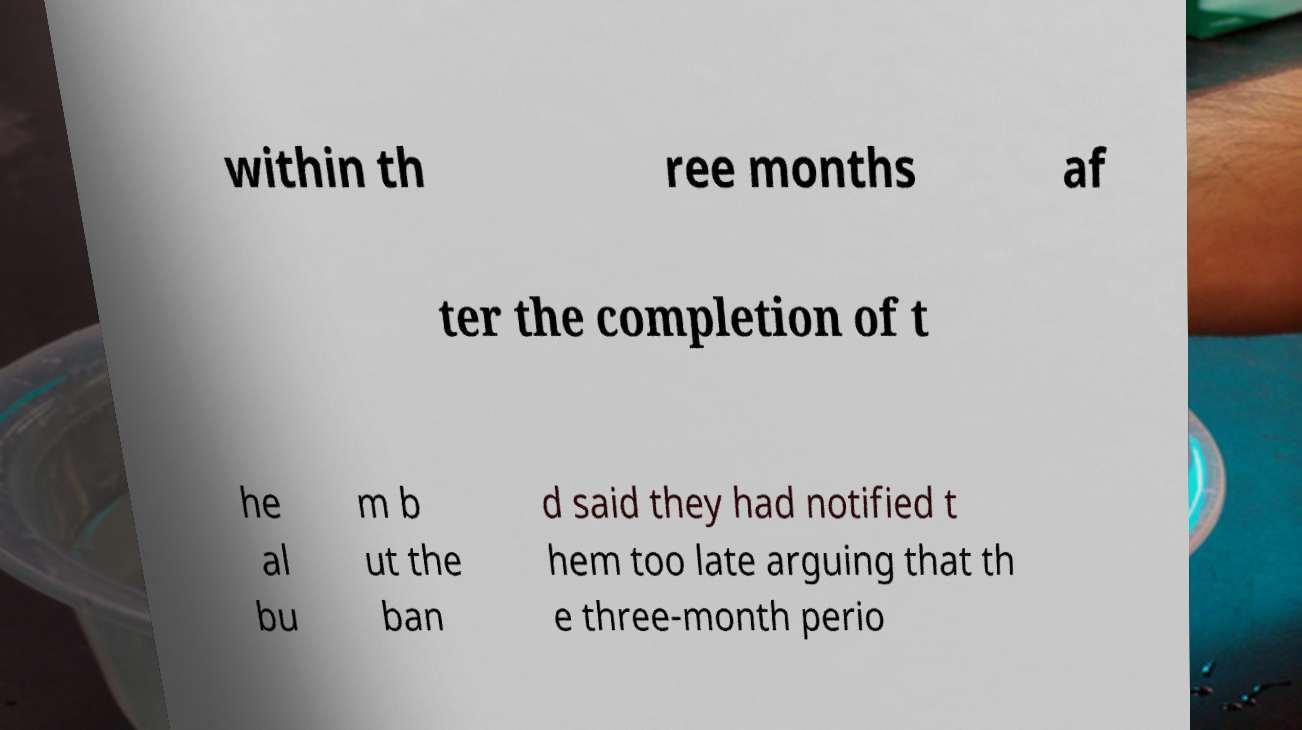Please identify and transcribe the text found in this image. within th ree months af ter the completion of t he al bu m b ut the ban d said they had notified t hem too late arguing that th e three-month perio 